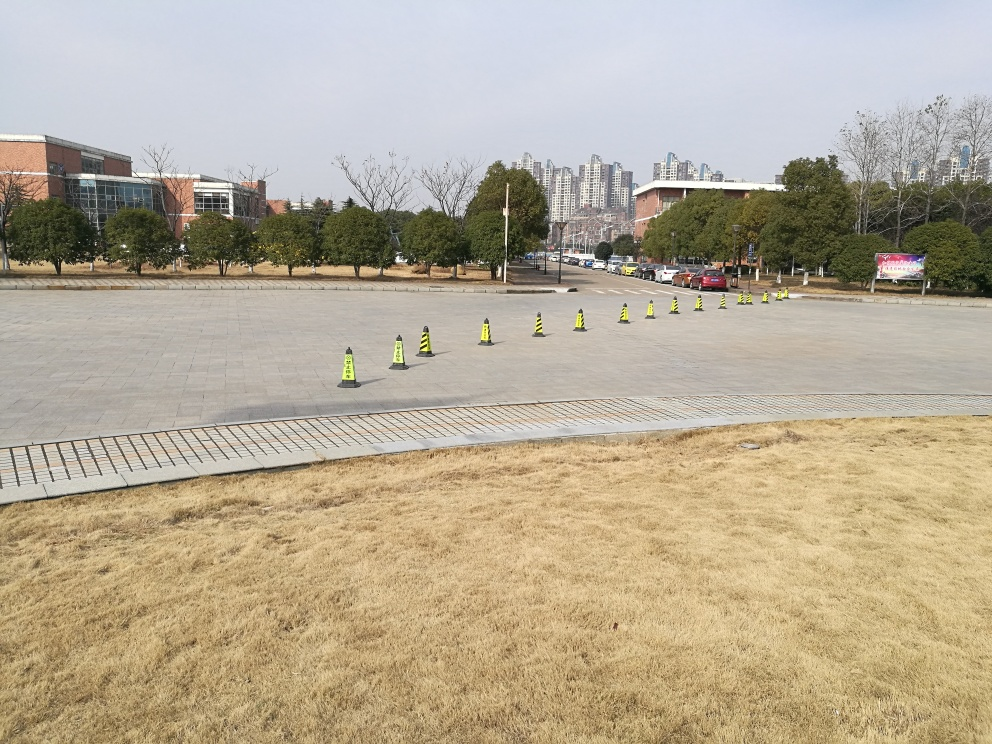What might be the purpose of these traffic cones in this location? The traffic cones are strategically placed in a pattern, which suggests they may serve to demarcate specific areas, such as a pedestrian path or to delineate an area where an outdoor event is set to take place. Their arrangement seems intentional, emphasizing guidance or separation rather than random placement. 